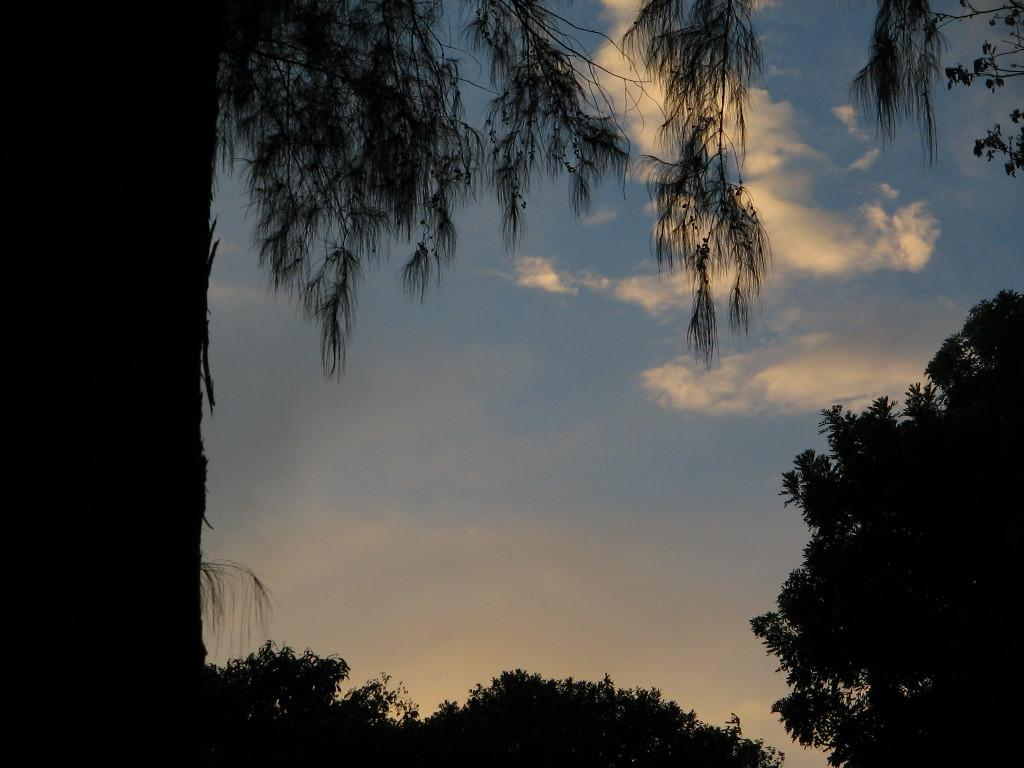What type of vegetation can be seen in the image? There are trees in the image. What is visible in the background of the image? The sky is visible in the image. What can be observed in the sky? Clouds are present in the sky. What type of whistle is the stranger wearing around their neck in the image? There is no stranger or whistle present in the image. What color is the scarf that the stranger is wearing in the image? There is no stranger or scarf present in the image. 